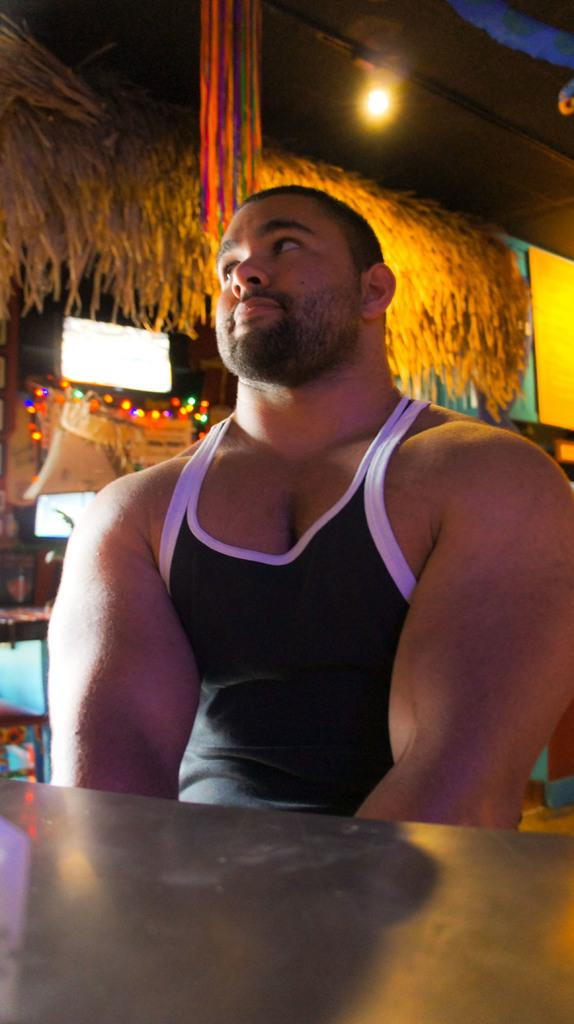Who or what is present in the image? There is a person in the image. Where is the person located in relation to other objects? The person is near a table. What can be seen in the image that provides illumination? There are lights in the image. What type of electronic device is visible in the image? There is a television in the image. What type of structure is present in the image? There is a hut in the image. What other objects can be seen in the image besides those mentioned? There are other objects present in the image. What type of tax is being discussed in the image? There is no discussion of tax in the image; it features a person near a table with lights, a television, a hut, and other objects. What kind of bird can be seen flying in the image? There are no birds present in the image. 